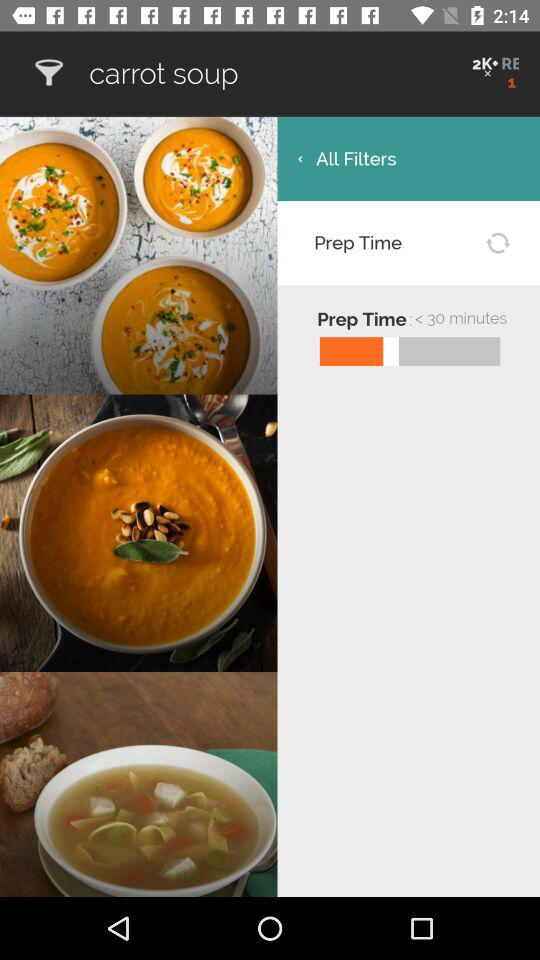What is the prep time? The prep time is less than 30 minutes. 